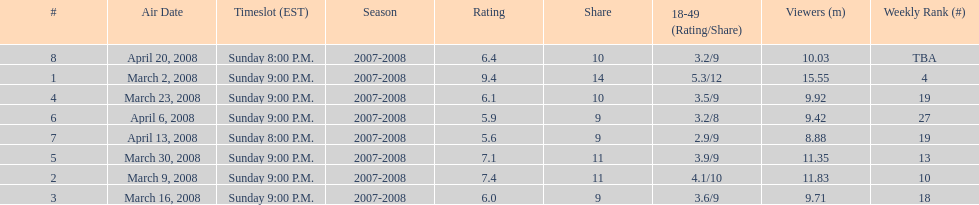How many shows had at least 10 million viewers? 4. I'm looking to parse the entire table for insights. Could you assist me with that? {'header': ['#', 'Air Date', 'Timeslot (EST)', 'Season', 'Rating', 'Share', '18-49 (Rating/Share)', 'Viewers (m)', 'Weekly Rank (#)'], 'rows': [['8', 'April 20, 2008', 'Sunday 8:00 P.M.', '2007-2008', '6.4', '10', '3.2/9', '10.03', 'TBA'], ['1', 'March 2, 2008', 'Sunday 9:00 P.M.', '2007-2008', '9.4', '14', '5.3/12', '15.55', '4'], ['4', 'March 23, 2008', 'Sunday 9:00 P.M.', '2007-2008', '6.1', '10', '3.5/9', '9.92', '19'], ['6', 'April 6, 2008', 'Sunday 9:00 P.M.', '2007-2008', '5.9', '9', '3.2/8', '9.42', '27'], ['7', 'April 13, 2008', 'Sunday 8:00 P.M.', '2007-2008', '5.6', '9', '2.9/9', '8.88', '19'], ['5', 'March 30, 2008', 'Sunday 9:00 P.M.', '2007-2008', '7.1', '11', '3.9/9', '11.35', '13'], ['2', 'March 9, 2008', 'Sunday 9:00 P.M.', '2007-2008', '7.4', '11', '4.1/10', '11.83', '10'], ['3', 'March 16, 2008', 'Sunday 9:00 P.M.', '2007-2008', '6.0', '9', '3.6/9', '9.71', '18']]} 